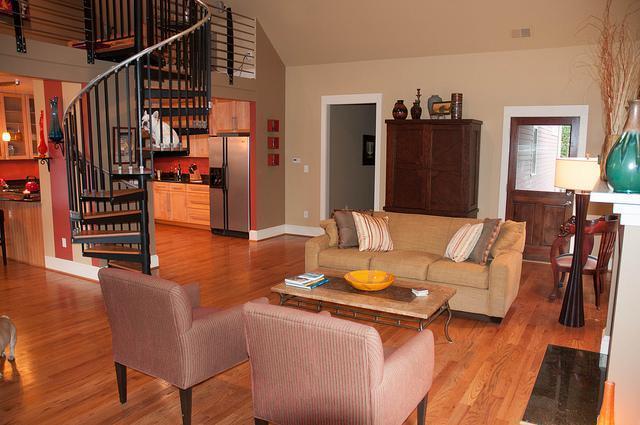How many chairs are seen?
Give a very brief answer. 3. How many chairs are visible?
Give a very brief answer. 3. How many white trucks can you see?
Give a very brief answer. 0. 